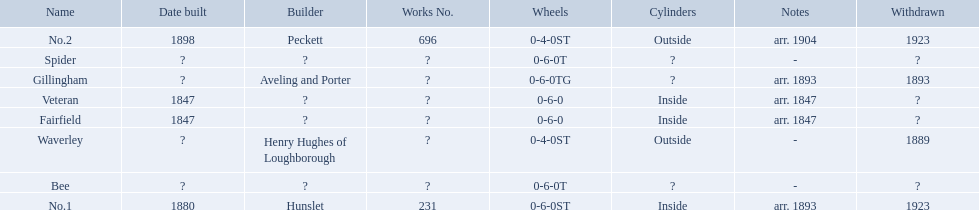What are the aldernay railways? Veteran, Fairfield, Waverley, Bee, Spider, Gillingham, No.1, No.2. Which ones were built in 1847? Veteran, Fairfield. Of those, which one is not fairfield? Veteran. 